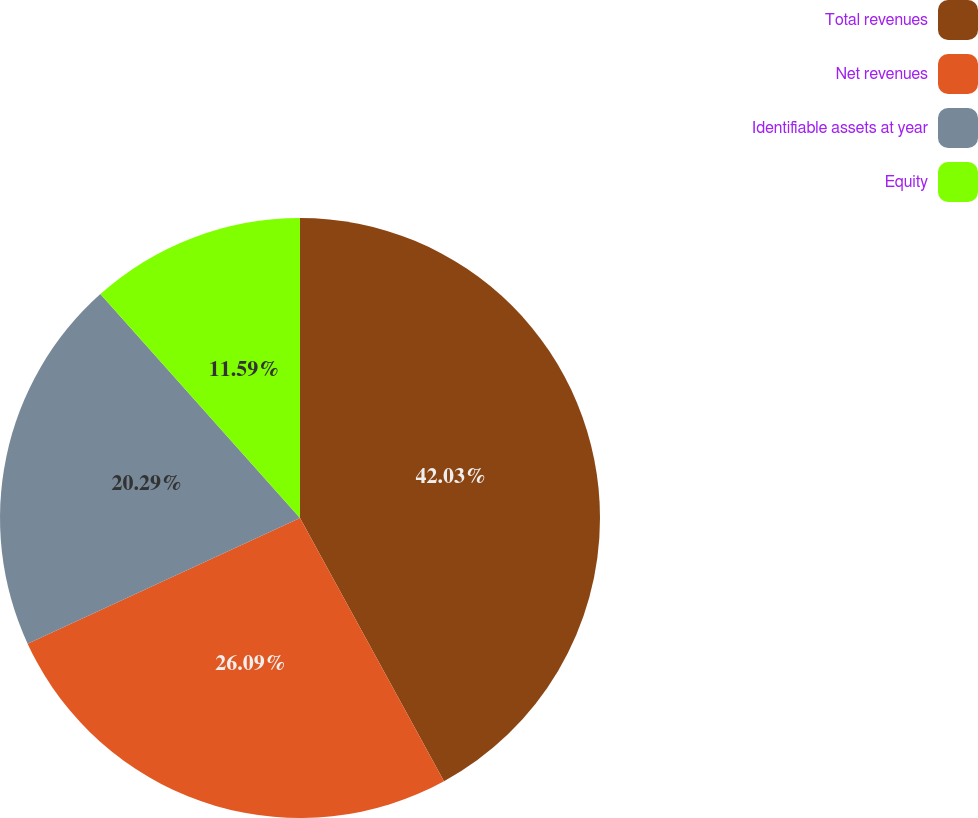<chart> <loc_0><loc_0><loc_500><loc_500><pie_chart><fcel>Total revenues<fcel>Net revenues<fcel>Identifiable assets at year<fcel>Equity<nl><fcel>42.03%<fcel>26.09%<fcel>20.29%<fcel>11.59%<nl></chart> 